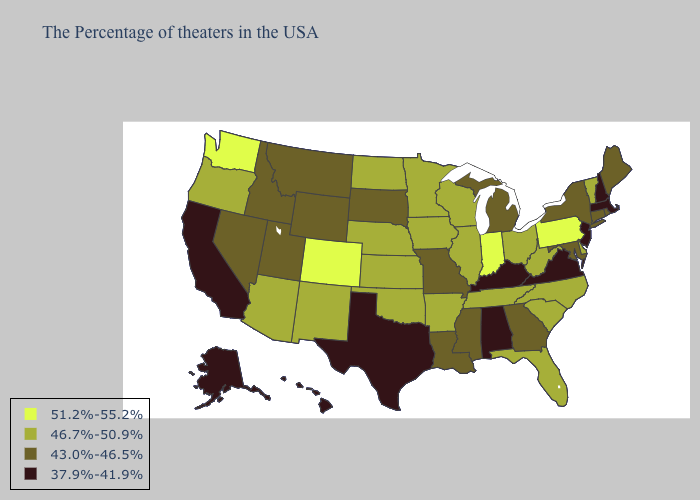Among the states that border Oregon , which have the highest value?
Short answer required. Washington. Does the first symbol in the legend represent the smallest category?
Give a very brief answer. No. What is the highest value in the USA?
Give a very brief answer. 51.2%-55.2%. Name the states that have a value in the range 51.2%-55.2%?
Short answer required. Pennsylvania, Indiana, Colorado, Washington. What is the value of Iowa?
Write a very short answer. 46.7%-50.9%. Does Utah have a higher value than Virginia?
Quick response, please. Yes. Does Michigan have the lowest value in the USA?
Concise answer only. No. Which states have the lowest value in the USA?
Write a very short answer. Massachusetts, New Hampshire, New Jersey, Virginia, Kentucky, Alabama, Texas, California, Alaska, Hawaii. Name the states that have a value in the range 46.7%-50.9%?
Quick response, please. Vermont, Delaware, North Carolina, South Carolina, West Virginia, Ohio, Florida, Tennessee, Wisconsin, Illinois, Arkansas, Minnesota, Iowa, Kansas, Nebraska, Oklahoma, North Dakota, New Mexico, Arizona, Oregon. What is the value of Delaware?
Give a very brief answer. 46.7%-50.9%. Name the states that have a value in the range 37.9%-41.9%?
Short answer required. Massachusetts, New Hampshire, New Jersey, Virginia, Kentucky, Alabama, Texas, California, Alaska, Hawaii. What is the value of Delaware?
Quick response, please. 46.7%-50.9%. Among the states that border Arkansas , which have the highest value?
Keep it brief. Tennessee, Oklahoma. Does Mississippi have a higher value than Kansas?
Short answer required. No. Does South Dakota have a higher value than Texas?
Write a very short answer. Yes. 